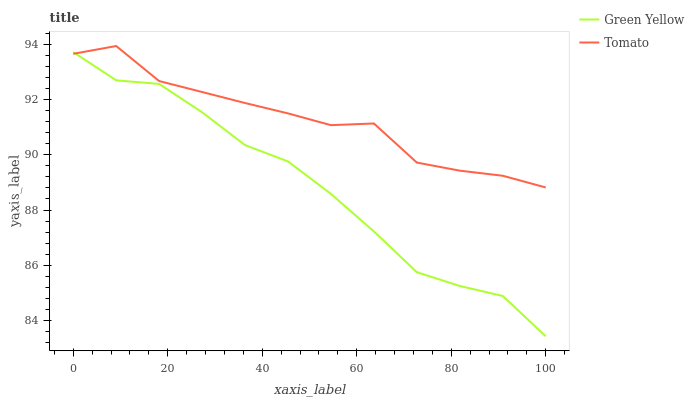Does Green Yellow have the minimum area under the curve?
Answer yes or no. Yes. Does Tomato have the maximum area under the curve?
Answer yes or no. Yes. Does Green Yellow have the maximum area under the curve?
Answer yes or no. No. Is Green Yellow the smoothest?
Answer yes or no. Yes. Is Tomato the roughest?
Answer yes or no. Yes. Is Green Yellow the roughest?
Answer yes or no. No. Does Green Yellow have the lowest value?
Answer yes or no. Yes. Does Tomato have the highest value?
Answer yes or no. Yes. Does Green Yellow have the highest value?
Answer yes or no. No. Does Tomato intersect Green Yellow?
Answer yes or no. Yes. Is Tomato less than Green Yellow?
Answer yes or no. No. Is Tomato greater than Green Yellow?
Answer yes or no. No. 